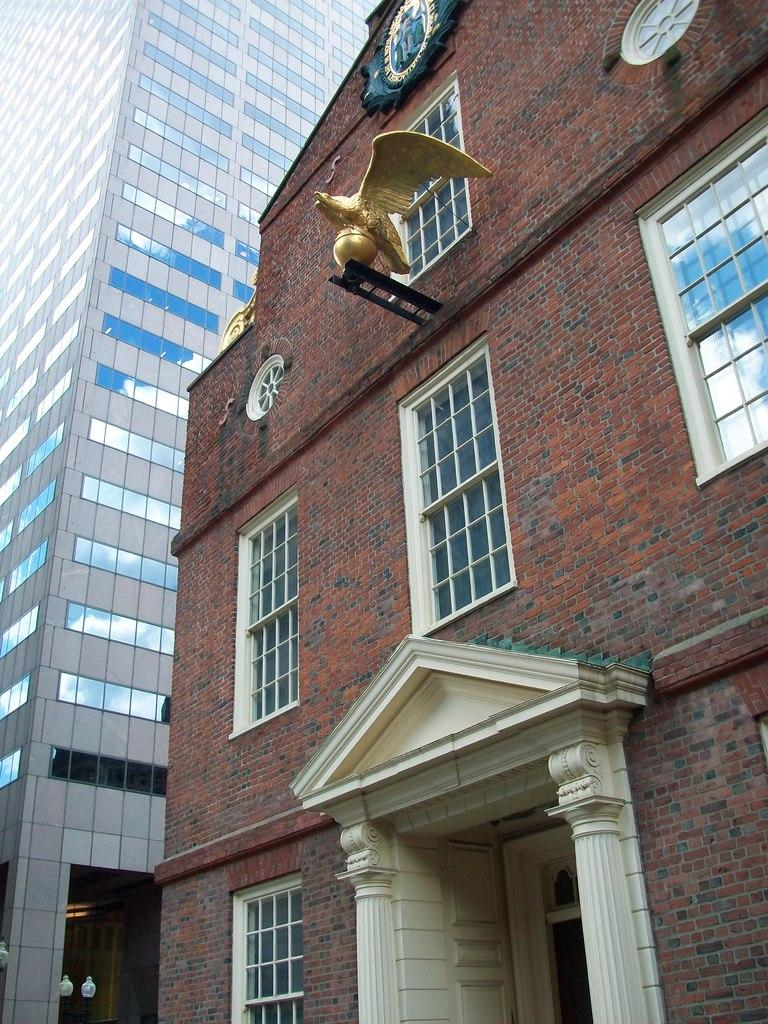What type of structures are visible in the image? There are buildings with windows in the image. What other object can be seen in the image besides the buildings? There is a statue with a stand in the image. How is the statue positioned in relation to the wall? The statue is attached to a wall. What can be observed on the wall in the image? There is a design on the wall in the image. How many girls are crying in the image? There are no girls or crying depicted in the image. What type of card is being held by the statue in the image? There is no card present in the image; the statue is attached to a wall with a design on it. 